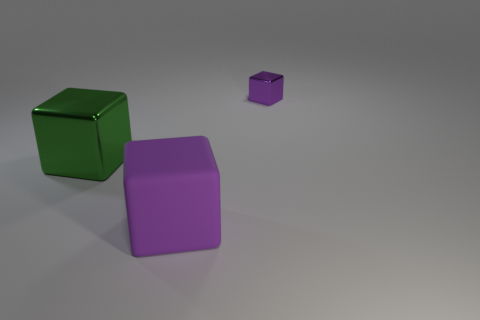Subtract all large cubes. How many cubes are left? 1 Subtract all blue spheres. How many purple cubes are left? 2 Subtract all green blocks. How many blocks are left? 2 Add 2 purple blocks. How many objects exist? 5 Subtract 1 green cubes. How many objects are left? 2 Subtract all green blocks. Subtract all cyan spheres. How many blocks are left? 2 Subtract all large shiny blocks. Subtract all large brown metal objects. How many objects are left? 2 Add 1 big cubes. How many big cubes are left? 3 Add 2 tiny red cylinders. How many tiny red cylinders exist? 2 